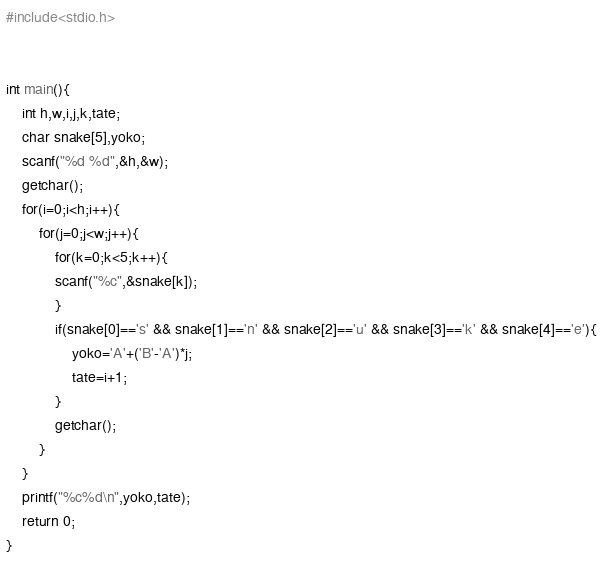<code> <loc_0><loc_0><loc_500><loc_500><_C_>#include<stdio.h>

 
int main(){
	int h,w,i,j,k,tate;
	char snake[5],yoko;
	scanf("%d %d",&h,&w);
	getchar();
	for(i=0;i<h;i++){
		for(j=0;j<w;j++){
			for(k=0;k<5;k++){
			scanf("%c",&snake[k]);
			}
			if(snake[0]=='s' && snake[1]=='n' && snake[2]=='u' && snake[3]=='k' && snake[4]=='e'){
				yoko='A'+('B'-'A')*j;
				tate=i+1;
			}
			getchar();
		}
	}
	printf("%c%d\n",yoko,tate);
	return 0;
}
</code> 